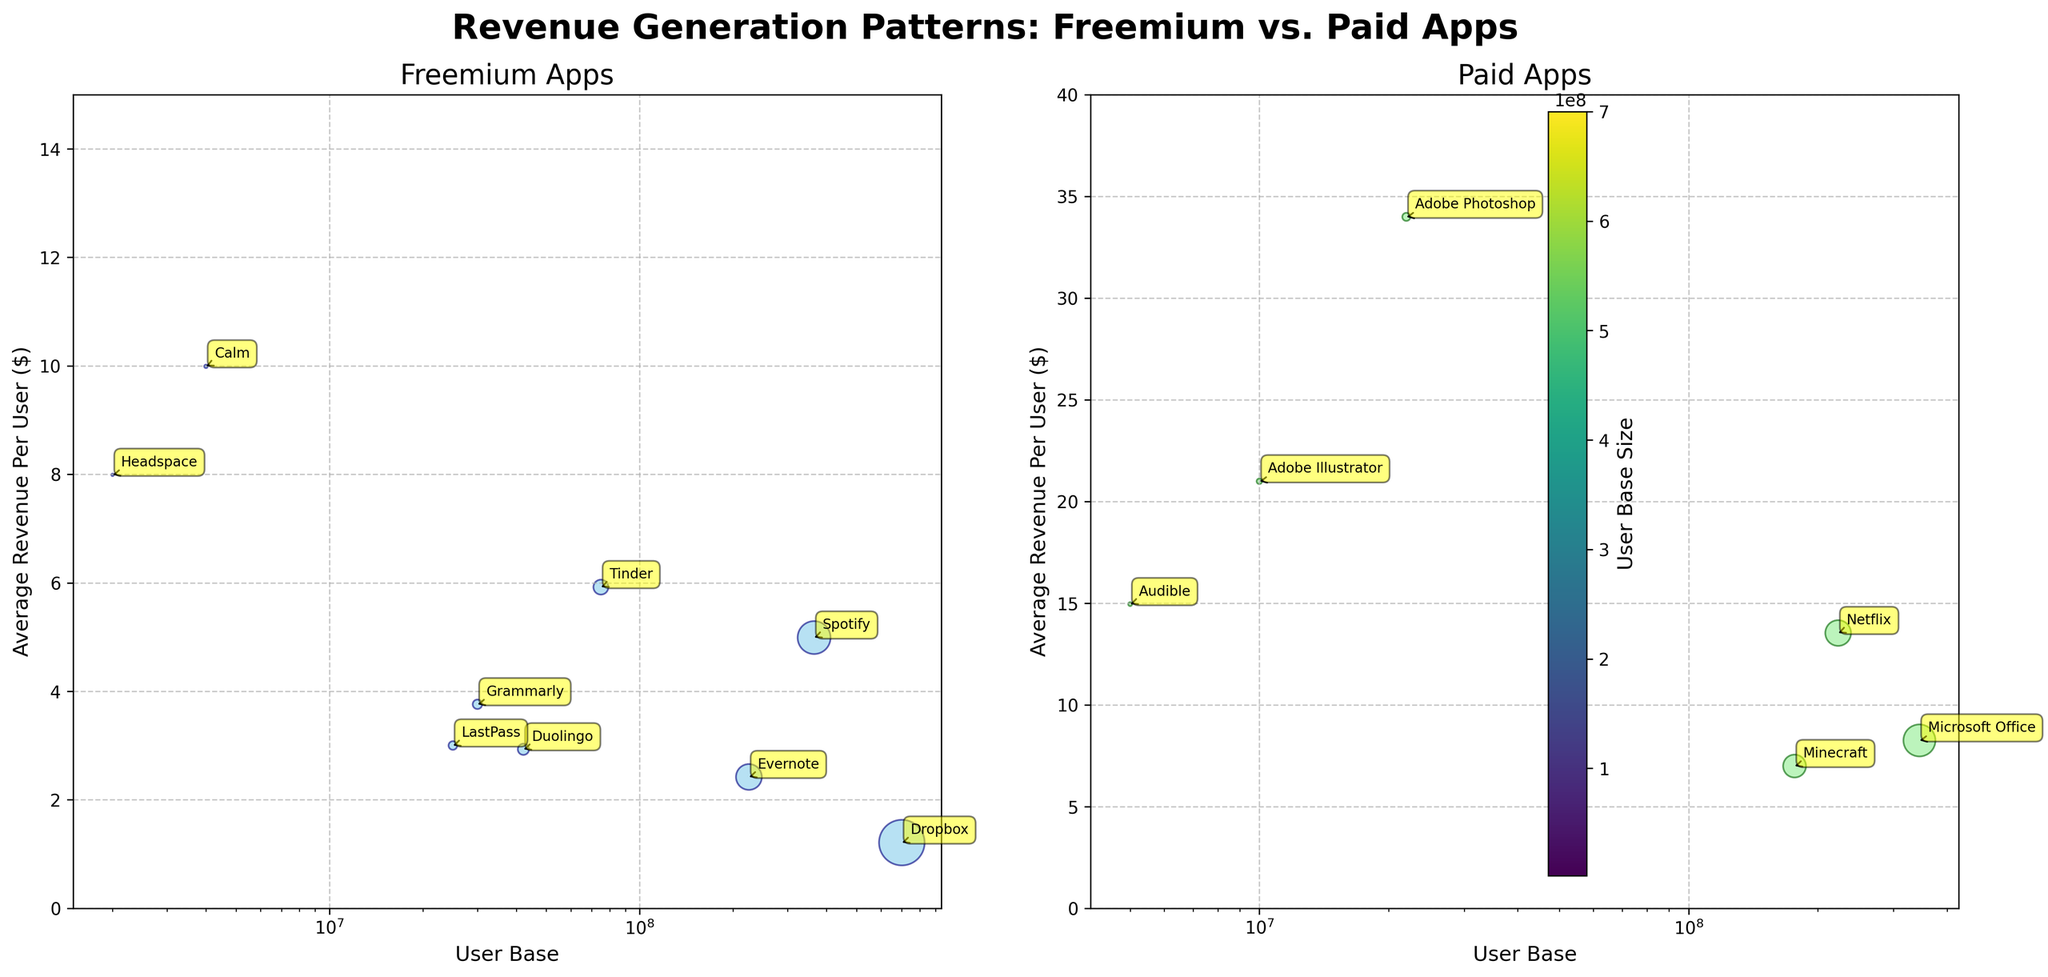what is the title of the figure? The title is at the center top of the figure, above the subplots. It is written in bold and large font: "Revenue Generation Patterns: Freemium vs. Paid Apps"
Answer: Revenue Generation Patterns: Freemium vs. Paid Apps which subplot shows freemium apps? There are two subplots side-by-side. The left subplot, labeled "Freemium Apps," shows the revenue and user base for freemium apps.
Answer: The left subplot how many apps are categorized as freemium? Each point on the left subplot represents a freemium app. Counting these points will give the number of freemium apps.
Answer: 8 what is the range of average revenue per user for paid apps? The y-axis of the right subplot shows the average revenue per user for paid apps, ranging from 0 to 40.
Answer: 0 to 40 dollars which freemium app has the highest user base? In the left subplot, the app with the largest circle (size represents user base) is the one with the highest user base, annotated as Dropbox.
Answer: Dropbox which paid app generates the highest average revenue per user? In the right subplot, check the y-values of the points and find the highest one. The annotated label will be Adobe Photoshop.
Answer: Adobe Photoshop compare the user base size between Spotify and Netflix, which one is larger? Viewing both subplots, you can compare the size of the circles for Spotify (left, representing freemium) and Netflix (right, representing paid). Spotify has a larger circle. double-checking the user base shown in the annotation, Spotify is larger.
Answer: Spotify which apps have an average revenue per user greater than 10 dollars? Check the subplots for points above the y-axis value of 10 dollars. In the freemium plot: Calm. In the paid plot: Netflix, Audible, Adobe Illustrator, Adobe Photoshop.
Answer: Calm, Netflix, Audible, Adobe Illustrator, Adobe Photoshop what visual feature is used to represent the user base size? The size of the circles (points) on both subplots represents the user base size. Larger circles indicate a larger user base.
Answer: The size of the circles what is the smallest user base size across all apps? Identify the smallest circle size across both subplots. The smallest circle size is in the freemium subplot, it is annotated as Headspace on visual inspection and double-check on the user base value is 2 million.
Answer: headspace 